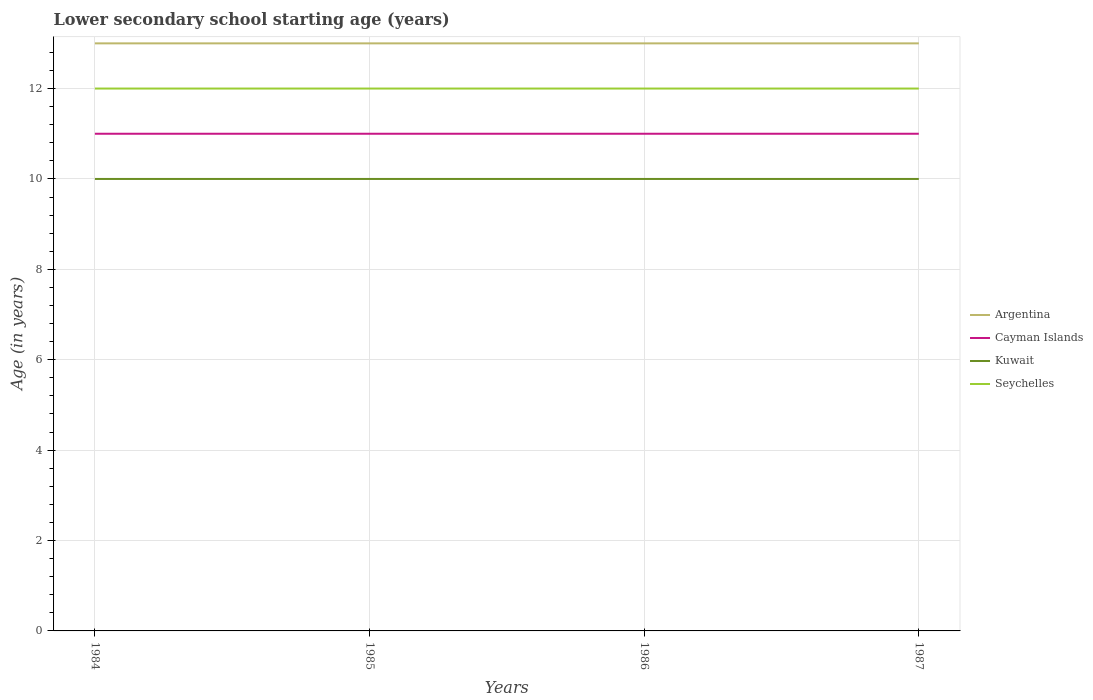How many different coloured lines are there?
Your answer should be compact. 4. Is the number of lines equal to the number of legend labels?
Keep it short and to the point. Yes. Across all years, what is the maximum lower secondary school starting age of children in Argentina?
Your response must be concise. 13. In which year was the lower secondary school starting age of children in Kuwait maximum?
Offer a very short reply. 1984. What is the total lower secondary school starting age of children in Argentina in the graph?
Give a very brief answer. 0. What is the difference between the highest and the second highest lower secondary school starting age of children in Kuwait?
Offer a very short reply. 0. Is the lower secondary school starting age of children in Seychelles strictly greater than the lower secondary school starting age of children in Argentina over the years?
Your answer should be very brief. Yes. How many lines are there?
Your response must be concise. 4. What is the difference between two consecutive major ticks on the Y-axis?
Provide a succinct answer. 2. Are the values on the major ticks of Y-axis written in scientific E-notation?
Provide a short and direct response. No. Does the graph contain any zero values?
Provide a short and direct response. No. Does the graph contain grids?
Offer a very short reply. Yes. Where does the legend appear in the graph?
Give a very brief answer. Center right. How many legend labels are there?
Offer a terse response. 4. How are the legend labels stacked?
Offer a terse response. Vertical. What is the title of the graph?
Keep it short and to the point. Lower secondary school starting age (years). What is the label or title of the X-axis?
Your answer should be very brief. Years. What is the label or title of the Y-axis?
Your answer should be compact. Age (in years). What is the Age (in years) in Seychelles in 1984?
Your response must be concise. 12. What is the Age (in years) of Argentina in 1985?
Provide a short and direct response. 13. What is the Age (in years) in Cayman Islands in 1985?
Your response must be concise. 11. What is the Age (in years) of Kuwait in 1985?
Your answer should be compact. 10. What is the Age (in years) in Cayman Islands in 1986?
Your response must be concise. 11. What is the Age (in years) of Argentina in 1987?
Ensure brevity in your answer.  13. What is the Age (in years) in Kuwait in 1987?
Give a very brief answer. 10. What is the Age (in years) in Seychelles in 1987?
Offer a very short reply. 12. Across all years, what is the maximum Age (in years) in Kuwait?
Provide a short and direct response. 10. Across all years, what is the minimum Age (in years) of Argentina?
Give a very brief answer. 13. Across all years, what is the minimum Age (in years) of Cayman Islands?
Offer a terse response. 11. Across all years, what is the minimum Age (in years) of Kuwait?
Your answer should be compact. 10. What is the total Age (in years) of Argentina in the graph?
Your answer should be compact. 52. What is the total Age (in years) in Kuwait in the graph?
Provide a succinct answer. 40. What is the total Age (in years) in Seychelles in the graph?
Provide a succinct answer. 48. What is the difference between the Age (in years) in Cayman Islands in 1984 and that in 1985?
Offer a very short reply. 0. What is the difference between the Age (in years) of Cayman Islands in 1984 and that in 1986?
Offer a terse response. 0. What is the difference between the Age (in years) in Kuwait in 1984 and that in 1986?
Provide a succinct answer. 0. What is the difference between the Age (in years) of Seychelles in 1984 and that in 1986?
Your answer should be compact. 0. What is the difference between the Age (in years) of Seychelles in 1984 and that in 1987?
Keep it short and to the point. 0. What is the difference between the Age (in years) in Argentina in 1985 and that in 1986?
Your answer should be very brief. 0. What is the difference between the Age (in years) in Seychelles in 1985 and that in 1986?
Offer a very short reply. 0. What is the difference between the Age (in years) in Kuwait in 1985 and that in 1987?
Give a very brief answer. 0. What is the difference between the Age (in years) of Seychelles in 1985 and that in 1987?
Provide a short and direct response. 0. What is the difference between the Age (in years) of Argentina in 1986 and that in 1987?
Provide a succinct answer. 0. What is the difference between the Age (in years) of Cayman Islands in 1986 and that in 1987?
Keep it short and to the point. 0. What is the difference between the Age (in years) in Seychelles in 1986 and that in 1987?
Your response must be concise. 0. What is the difference between the Age (in years) in Argentina in 1984 and the Age (in years) in Cayman Islands in 1985?
Offer a terse response. 2. What is the difference between the Age (in years) of Argentina in 1984 and the Age (in years) of Kuwait in 1985?
Your response must be concise. 3. What is the difference between the Age (in years) in Argentina in 1984 and the Age (in years) in Seychelles in 1985?
Your answer should be compact. 1. What is the difference between the Age (in years) in Cayman Islands in 1984 and the Age (in years) in Seychelles in 1985?
Offer a terse response. -1. What is the difference between the Age (in years) of Kuwait in 1984 and the Age (in years) of Seychelles in 1985?
Make the answer very short. -2. What is the difference between the Age (in years) of Argentina in 1984 and the Age (in years) of Cayman Islands in 1986?
Offer a very short reply. 2. What is the difference between the Age (in years) of Argentina in 1984 and the Age (in years) of Kuwait in 1986?
Keep it short and to the point. 3. What is the difference between the Age (in years) of Cayman Islands in 1984 and the Age (in years) of Seychelles in 1986?
Your response must be concise. -1. What is the difference between the Age (in years) of Argentina in 1984 and the Age (in years) of Cayman Islands in 1987?
Provide a short and direct response. 2. What is the difference between the Age (in years) in Argentina in 1985 and the Age (in years) in Seychelles in 1986?
Provide a succinct answer. 1. What is the difference between the Age (in years) of Kuwait in 1985 and the Age (in years) of Seychelles in 1986?
Keep it short and to the point. -2. What is the difference between the Age (in years) of Argentina in 1985 and the Age (in years) of Cayman Islands in 1987?
Your response must be concise. 2. What is the difference between the Age (in years) in Argentina in 1985 and the Age (in years) in Seychelles in 1987?
Ensure brevity in your answer.  1. What is the difference between the Age (in years) in Cayman Islands in 1985 and the Age (in years) in Kuwait in 1987?
Provide a succinct answer. 1. What is the difference between the Age (in years) of Cayman Islands in 1985 and the Age (in years) of Seychelles in 1987?
Make the answer very short. -1. What is the difference between the Age (in years) of Kuwait in 1985 and the Age (in years) of Seychelles in 1987?
Keep it short and to the point. -2. What is the difference between the Age (in years) in Argentina in 1986 and the Age (in years) in Cayman Islands in 1987?
Offer a terse response. 2. What is the difference between the Age (in years) of Argentina in 1986 and the Age (in years) of Kuwait in 1987?
Your answer should be compact. 3. What is the average Age (in years) of Argentina per year?
Provide a short and direct response. 13. What is the average Age (in years) in Cayman Islands per year?
Provide a short and direct response. 11. What is the average Age (in years) in Seychelles per year?
Your answer should be compact. 12. In the year 1984, what is the difference between the Age (in years) in Argentina and Age (in years) in Kuwait?
Offer a very short reply. 3. In the year 1984, what is the difference between the Age (in years) of Kuwait and Age (in years) of Seychelles?
Your answer should be very brief. -2. In the year 1985, what is the difference between the Age (in years) of Argentina and Age (in years) of Seychelles?
Your answer should be very brief. 1. In the year 1985, what is the difference between the Age (in years) of Cayman Islands and Age (in years) of Kuwait?
Offer a terse response. 1. In the year 1985, what is the difference between the Age (in years) in Cayman Islands and Age (in years) in Seychelles?
Ensure brevity in your answer.  -1. In the year 1985, what is the difference between the Age (in years) of Kuwait and Age (in years) of Seychelles?
Keep it short and to the point. -2. In the year 1986, what is the difference between the Age (in years) of Argentina and Age (in years) of Cayman Islands?
Offer a terse response. 2. In the year 1986, what is the difference between the Age (in years) of Argentina and Age (in years) of Kuwait?
Ensure brevity in your answer.  3. In the year 1986, what is the difference between the Age (in years) in Cayman Islands and Age (in years) in Kuwait?
Make the answer very short. 1. In the year 1986, what is the difference between the Age (in years) of Cayman Islands and Age (in years) of Seychelles?
Provide a succinct answer. -1. In the year 1987, what is the difference between the Age (in years) in Argentina and Age (in years) in Cayman Islands?
Keep it short and to the point. 2. In the year 1987, what is the difference between the Age (in years) in Argentina and Age (in years) in Kuwait?
Make the answer very short. 3. In the year 1987, what is the difference between the Age (in years) of Cayman Islands and Age (in years) of Kuwait?
Provide a short and direct response. 1. What is the ratio of the Age (in years) of Argentina in 1984 to that in 1985?
Your response must be concise. 1. What is the ratio of the Age (in years) of Cayman Islands in 1984 to that in 1986?
Give a very brief answer. 1. What is the ratio of the Age (in years) in Kuwait in 1984 to that in 1986?
Your response must be concise. 1. What is the ratio of the Age (in years) in Argentina in 1984 to that in 1987?
Ensure brevity in your answer.  1. What is the ratio of the Age (in years) in Cayman Islands in 1984 to that in 1987?
Offer a very short reply. 1. What is the ratio of the Age (in years) of Cayman Islands in 1985 to that in 1986?
Ensure brevity in your answer.  1. What is the ratio of the Age (in years) in Kuwait in 1985 to that in 1986?
Provide a short and direct response. 1. What is the ratio of the Age (in years) of Cayman Islands in 1985 to that in 1987?
Your answer should be compact. 1. What is the ratio of the Age (in years) of Kuwait in 1986 to that in 1987?
Provide a short and direct response. 1. What is the difference between the highest and the second highest Age (in years) of Argentina?
Ensure brevity in your answer.  0. What is the difference between the highest and the second highest Age (in years) in Seychelles?
Provide a succinct answer. 0. What is the difference between the highest and the lowest Age (in years) of Argentina?
Give a very brief answer. 0. What is the difference between the highest and the lowest Age (in years) in Seychelles?
Your response must be concise. 0. 